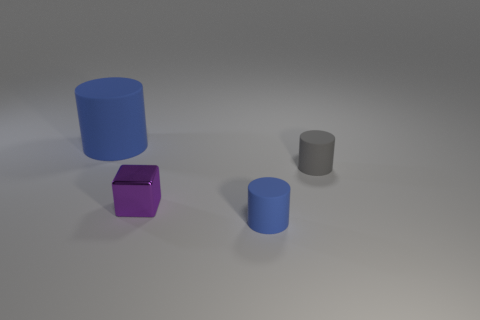There is a large blue thing; are there any big blue matte things in front of it?
Offer a terse response. No. Do the purple object and the gray cylinder have the same size?
Make the answer very short. Yes. The blue thing that is on the right side of the tiny metal thing has what shape?
Give a very brief answer. Cylinder. Are there any red matte cylinders of the same size as the metallic cube?
Ensure brevity in your answer.  No. What material is the blue cylinder that is the same size as the gray rubber thing?
Your answer should be compact. Rubber. There is a blue rubber thing that is to the left of the purple object; how big is it?
Your answer should be very brief. Large. What is the size of the gray matte cylinder?
Offer a very short reply. Small. Is the size of the purple metallic block the same as the blue object to the right of the big blue matte cylinder?
Make the answer very short. Yes. What color is the rubber thing to the left of the purple shiny cube that is to the left of the gray thing?
Your response must be concise. Blue. Is the number of tiny blue matte objects that are behind the metal object the same as the number of metal things behind the big matte thing?
Your answer should be very brief. Yes. 